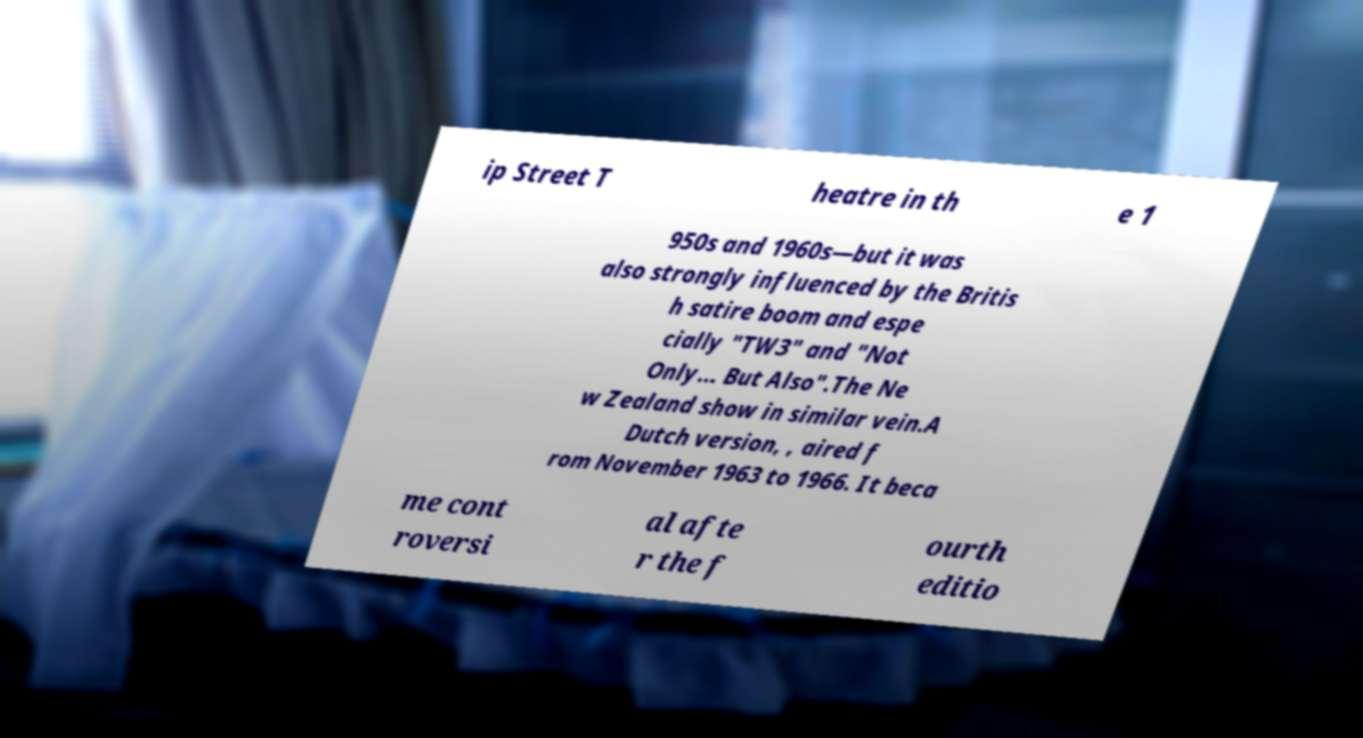What messages or text are displayed in this image? I need them in a readable, typed format. ip Street T heatre in th e 1 950s and 1960s—but it was also strongly influenced by the Britis h satire boom and espe cially "TW3" and "Not Only... But Also".The Ne w Zealand show in similar vein.A Dutch version, , aired f rom November 1963 to 1966. It beca me cont roversi al afte r the f ourth editio 